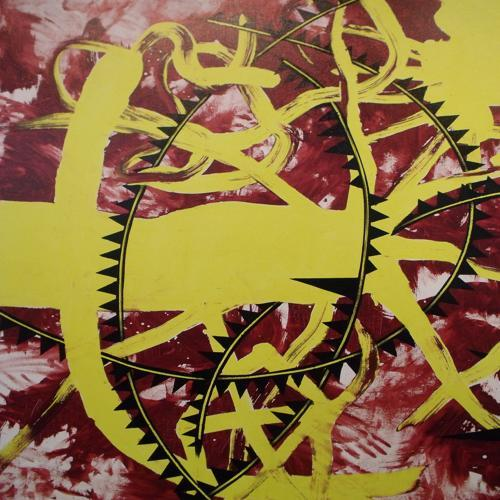Is the composition of the image acceptable?
A. no
B. unbalanced
C. yes
Answer with the option's letter from the given choices directly.
 C. 